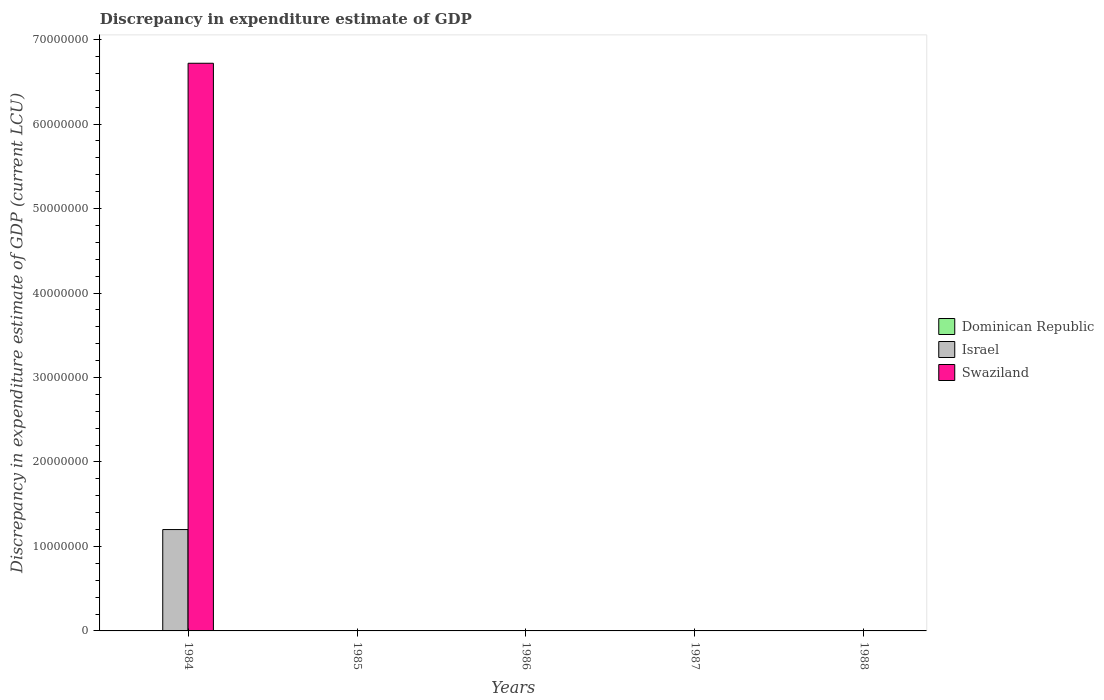Are the number of bars per tick equal to the number of legend labels?
Your answer should be very brief. No. How many bars are there on the 2nd tick from the left?
Offer a terse response. 1. How many bars are there on the 3rd tick from the right?
Offer a very short reply. 1. In how many cases, is the number of bars for a given year not equal to the number of legend labels?
Your answer should be very brief. 5. What is the discrepancy in expenditure estimate of GDP in Israel in 1984?
Keep it short and to the point. 1.20e+07. Across all years, what is the maximum discrepancy in expenditure estimate of GDP in Israel?
Provide a short and direct response. 1.20e+07. Across all years, what is the minimum discrepancy in expenditure estimate of GDP in Israel?
Provide a succinct answer. 0. In which year was the discrepancy in expenditure estimate of GDP in Dominican Republic maximum?
Make the answer very short. 1988. What is the total discrepancy in expenditure estimate of GDP in Dominican Republic in the graph?
Give a very brief answer. 1300. What is the average discrepancy in expenditure estimate of GDP in Dominican Republic per year?
Offer a very short reply. 260. In the year 1988, what is the difference between the discrepancy in expenditure estimate of GDP in Dominican Republic and discrepancy in expenditure estimate of GDP in Israel?
Provide a short and direct response. -1200. What is the ratio of the discrepancy in expenditure estimate of GDP in Dominican Republic in 1987 to that in 1988?
Provide a short and direct response. 0.3. Is the discrepancy in expenditure estimate of GDP in Swaziland in 1985 less than that in 1986?
Make the answer very short. No. What is the difference between the highest and the second highest discrepancy in expenditure estimate of GDP in Swaziland?
Offer a terse response. 6.72e+07. What is the difference between the highest and the lowest discrepancy in expenditure estimate of GDP in Dominican Republic?
Provide a succinct answer. 1000. In how many years, is the discrepancy in expenditure estimate of GDP in Swaziland greater than the average discrepancy in expenditure estimate of GDP in Swaziland taken over all years?
Offer a very short reply. 1. Is the sum of the discrepancy in expenditure estimate of GDP in Swaziland in 1984 and 1986 greater than the maximum discrepancy in expenditure estimate of GDP in Israel across all years?
Your answer should be compact. Yes. Is it the case that in every year, the sum of the discrepancy in expenditure estimate of GDP in Dominican Republic and discrepancy in expenditure estimate of GDP in Israel is greater than the discrepancy in expenditure estimate of GDP in Swaziland?
Keep it short and to the point. No. How many bars are there?
Keep it short and to the point. 7. How many years are there in the graph?
Give a very brief answer. 5. Are the values on the major ticks of Y-axis written in scientific E-notation?
Make the answer very short. No. Does the graph contain any zero values?
Provide a succinct answer. Yes. What is the title of the graph?
Give a very brief answer. Discrepancy in expenditure estimate of GDP. What is the label or title of the X-axis?
Your response must be concise. Years. What is the label or title of the Y-axis?
Your response must be concise. Discrepancy in expenditure estimate of GDP (current LCU). What is the Discrepancy in expenditure estimate of GDP (current LCU) in Dominican Republic in 1984?
Provide a succinct answer. 0. What is the Discrepancy in expenditure estimate of GDP (current LCU) of Israel in 1984?
Provide a succinct answer. 1.20e+07. What is the Discrepancy in expenditure estimate of GDP (current LCU) in Swaziland in 1984?
Make the answer very short. 6.72e+07. What is the Discrepancy in expenditure estimate of GDP (current LCU) of Dominican Republic in 1985?
Provide a short and direct response. 0. What is the Discrepancy in expenditure estimate of GDP (current LCU) of Israel in 1985?
Ensure brevity in your answer.  0. What is the Discrepancy in expenditure estimate of GDP (current LCU) in Swaziland in 1985?
Offer a terse response. 1.2e-7. What is the Discrepancy in expenditure estimate of GDP (current LCU) in Israel in 1986?
Provide a succinct answer. 0. What is the Discrepancy in expenditure estimate of GDP (current LCU) in Swaziland in 1986?
Your response must be concise. 9e-8. What is the Discrepancy in expenditure estimate of GDP (current LCU) of Dominican Republic in 1987?
Provide a succinct answer. 300. What is the Discrepancy in expenditure estimate of GDP (current LCU) in Israel in 1987?
Your answer should be very brief. 0. What is the Discrepancy in expenditure estimate of GDP (current LCU) in Dominican Republic in 1988?
Keep it short and to the point. 1000. What is the Discrepancy in expenditure estimate of GDP (current LCU) of Israel in 1988?
Offer a terse response. 2200. Across all years, what is the maximum Discrepancy in expenditure estimate of GDP (current LCU) in Dominican Republic?
Your answer should be compact. 1000. Across all years, what is the maximum Discrepancy in expenditure estimate of GDP (current LCU) in Israel?
Offer a terse response. 1.20e+07. Across all years, what is the maximum Discrepancy in expenditure estimate of GDP (current LCU) in Swaziland?
Your answer should be compact. 6.72e+07. Across all years, what is the minimum Discrepancy in expenditure estimate of GDP (current LCU) in Dominican Republic?
Give a very brief answer. 0. What is the total Discrepancy in expenditure estimate of GDP (current LCU) in Dominican Republic in the graph?
Offer a terse response. 1300. What is the total Discrepancy in expenditure estimate of GDP (current LCU) in Israel in the graph?
Your response must be concise. 1.20e+07. What is the total Discrepancy in expenditure estimate of GDP (current LCU) in Swaziland in the graph?
Provide a short and direct response. 6.72e+07. What is the difference between the Discrepancy in expenditure estimate of GDP (current LCU) of Swaziland in 1984 and that in 1985?
Provide a short and direct response. 6.72e+07. What is the difference between the Discrepancy in expenditure estimate of GDP (current LCU) in Swaziland in 1984 and that in 1986?
Provide a short and direct response. 6.72e+07. What is the difference between the Discrepancy in expenditure estimate of GDP (current LCU) in Israel in 1984 and that in 1988?
Offer a very short reply. 1.20e+07. What is the difference between the Discrepancy in expenditure estimate of GDP (current LCU) of Dominican Republic in 1987 and that in 1988?
Give a very brief answer. -700. What is the difference between the Discrepancy in expenditure estimate of GDP (current LCU) of Israel in 1984 and the Discrepancy in expenditure estimate of GDP (current LCU) of Swaziland in 1985?
Provide a short and direct response. 1.20e+07. What is the difference between the Discrepancy in expenditure estimate of GDP (current LCU) of Israel in 1984 and the Discrepancy in expenditure estimate of GDP (current LCU) of Swaziland in 1986?
Your answer should be compact. 1.20e+07. What is the difference between the Discrepancy in expenditure estimate of GDP (current LCU) of Dominican Republic in 1987 and the Discrepancy in expenditure estimate of GDP (current LCU) of Israel in 1988?
Make the answer very short. -1900. What is the average Discrepancy in expenditure estimate of GDP (current LCU) of Dominican Republic per year?
Provide a succinct answer. 260. What is the average Discrepancy in expenditure estimate of GDP (current LCU) in Israel per year?
Ensure brevity in your answer.  2.40e+06. What is the average Discrepancy in expenditure estimate of GDP (current LCU) in Swaziland per year?
Your answer should be very brief. 1.34e+07. In the year 1984, what is the difference between the Discrepancy in expenditure estimate of GDP (current LCU) of Israel and Discrepancy in expenditure estimate of GDP (current LCU) of Swaziland?
Make the answer very short. -5.52e+07. In the year 1988, what is the difference between the Discrepancy in expenditure estimate of GDP (current LCU) in Dominican Republic and Discrepancy in expenditure estimate of GDP (current LCU) in Israel?
Ensure brevity in your answer.  -1200. What is the ratio of the Discrepancy in expenditure estimate of GDP (current LCU) in Swaziland in 1984 to that in 1985?
Give a very brief answer. 5.60e+14. What is the ratio of the Discrepancy in expenditure estimate of GDP (current LCU) in Swaziland in 1984 to that in 1986?
Keep it short and to the point. 7.47e+14. What is the ratio of the Discrepancy in expenditure estimate of GDP (current LCU) of Israel in 1984 to that in 1988?
Your response must be concise. 5454.27. What is the ratio of the Discrepancy in expenditure estimate of GDP (current LCU) of Swaziland in 1985 to that in 1986?
Make the answer very short. 1.33. What is the ratio of the Discrepancy in expenditure estimate of GDP (current LCU) of Dominican Republic in 1987 to that in 1988?
Give a very brief answer. 0.3. What is the difference between the highest and the second highest Discrepancy in expenditure estimate of GDP (current LCU) of Swaziland?
Offer a very short reply. 6.72e+07. What is the difference between the highest and the lowest Discrepancy in expenditure estimate of GDP (current LCU) of Israel?
Your response must be concise. 1.20e+07. What is the difference between the highest and the lowest Discrepancy in expenditure estimate of GDP (current LCU) of Swaziland?
Your answer should be compact. 6.72e+07. 